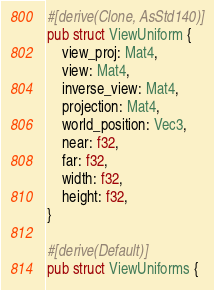Convert code to text. <code><loc_0><loc_0><loc_500><loc_500><_Rust_>#[derive(Clone, AsStd140)]
pub struct ViewUniform {
    view_proj: Mat4,
    view: Mat4,
    inverse_view: Mat4,
    projection: Mat4,
    world_position: Vec3,
    near: f32,
    far: f32,
    width: f32,
    height: f32,
}

#[derive(Default)]
pub struct ViewUniforms {</code> 